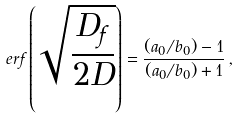Convert formula to latex. <formula><loc_0><loc_0><loc_500><loc_500>e r f \left ( \sqrt { \frac { D _ { f } } { 2 D } } \right ) = \frac { ( a _ { 0 } / b _ { 0 } ) - 1 } { ( a _ { 0 } / b _ { 0 } ) + 1 } \, ,</formula> 